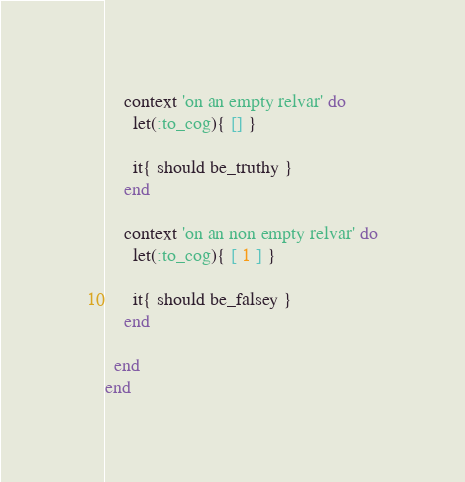Convert code to text. <code><loc_0><loc_0><loc_500><loc_500><_Ruby_>    context 'on an empty relvar' do
      let(:to_cog){ [] }

      it{ should be_truthy }
    end

    context 'on an non empty relvar' do
      let(:to_cog){ [ 1 ] }

      it{ should be_falsey }
    end

  end
end
</code> 